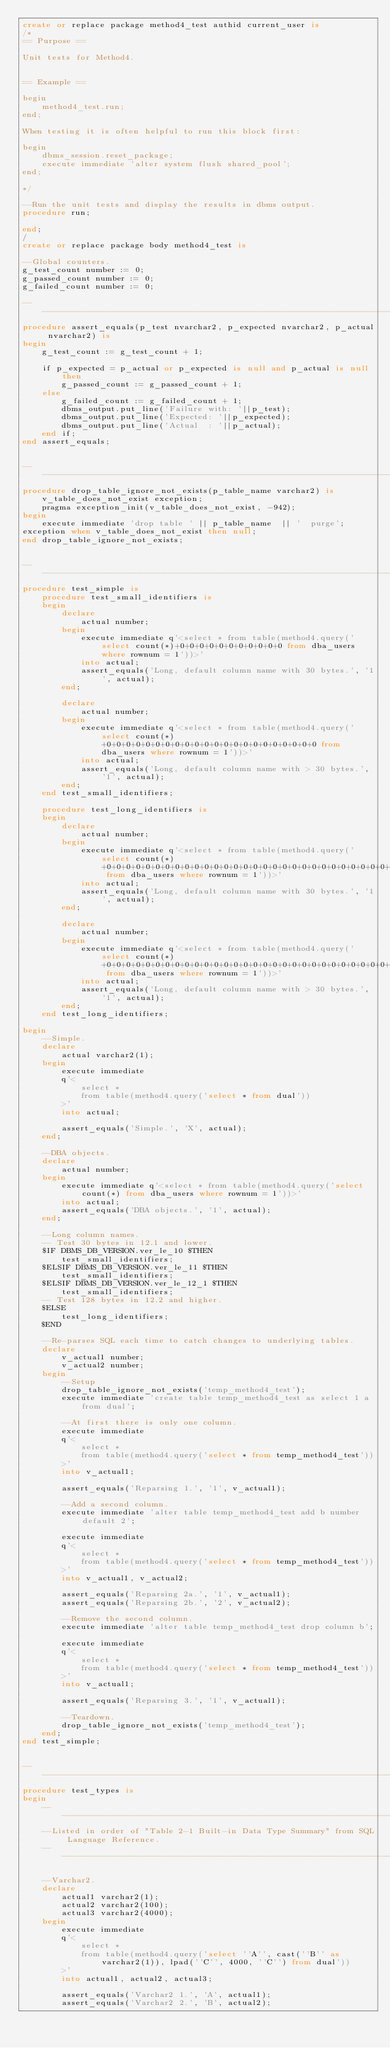<code> <loc_0><loc_0><loc_500><loc_500><_SQL_>create or replace package method4_test authid current_user is
/*
== Purpose ==

Unit tests for Method4.


== Example ==

begin
	method4_test.run;
end;

When testing it is often helpful to run this block first:

begin
	dbms_session.reset_package;
	execute immediate 'alter system flush shared_pool';
end;

*/

--Run the unit tests and display the results in dbms output.
procedure run;

end;
/
create or replace package body method4_test is

--Global counters.
g_test_count number := 0;
g_passed_count number := 0;
g_failed_count number := 0;

--------------------------------------------------------------------------------
procedure assert_equals(p_test nvarchar2, p_expected nvarchar2, p_actual nvarchar2) is
begin
	g_test_count := g_test_count + 1;

	if p_expected = p_actual or p_expected is null and p_actual is null then
		g_passed_count := g_passed_count + 1;
	else
		g_failed_count := g_failed_count + 1;
		dbms_output.put_line('Failure with: '||p_test);
		dbms_output.put_line('Expected: '||p_expected);
		dbms_output.put_line('Actual  : '||p_actual);
	end if;
end assert_equals;


--------------------------------------------------------------------------------
procedure drop_table_ignore_not_exists(p_table_name varchar2) is
	v_table_does_not_exist exception;
	pragma exception_init(v_table_does_not_exist, -942);
begin
	execute immediate 'drop table ' || p_table_name  || '  purge';
exception when v_table_does_not_exist then null;
end drop_table_ignore_not_exists;


--------------------------------------------------------------------------------
procedure test_simple is
	procedure test_small_identifiers is
	begin
		declare
			actual number;
		begin
			execute immediate q'<select * from table(method4.query('select count(*)+0+0+0+0+0+0+0+0+0+0+0 from dba_users where rownum = 1'))>'
			into actual;
			assert_equals('Long, default column name with 30 bytes.', '1', actual);
		end;

		declare
			actual number;
		begin
			execute immediate q'<select * from table(method4.query('select count(*)+0+0+0+0+0+0+0+0+0+0+0+0+0+0+0+0+0+0+0+0+0+0 from dba_users where rownum = 1'))>'
			into actual;
			assert_equals('Long, default column name with > 30 bytes.', '1', actual);
		end;
	end test_small_identifiers;

	procedure test_long_identifiers is
	begin
		declare
			actual number;
		begin
			execute immediate q'<select * from table(method4.query('select count(*)+0+0+0+0+0+0+0+0+0+0+0+0+0+0+0+0+0+0+0+0+0+0+0+0+0+0+0+0+0+0+0+0+0+0+0+0+0+0+0+0+0+0+0+0+0+0+0+0+0+0+0+0+0+0+0+0+0+0+0+0 from dba_users where rownum = 1'))>'
			into actual;
			assert_equals('Long, default column name with 30 bytes.', '1', actual);
		end;

		declare
			actual number;
		begin
			execute immediate q'<select * from table(method4.query('select count(*)+0+0+0+0+0+0+0+0+0+0+0+0+0+0+0+0+0+0+0+0+0+0+0+0+0+0+0+0+0+0+0+0+0+0+0+0+0+0+0+0+0+0+0+0+0+0+0+0+0+0+0+0+0+0+0+0+0+0+0+0+0+0+0+0+0+0+0+0 from dba_users where rownum = 1'))>'
			into actual;
			assert_equals('Long, default column name with > 30 bytes.', '1', actual);
		end;
	end test_long_identifiers;

begin
	--Simple.
	declare
		actual varchar2(1);
	begin
		execute immediate
		q'<
			select *
			from table(method4.query('select * from dual'))
		>'
		into actual;

		assert_equals('Simple.', 'X', actual);
	end;

	--DBA objects.
	declare
		actual number;
	begin
		execute immediate q'<select * from table(method4.query('select count(*) from dba_users where rownum = 1'))>'
		into actual;
		assert_equals('DBA objects.', '1', actual);
	end;

	--Long column names.
	-- Test 30 bytes in 12.1 and lower.
	$IF DBMS_DB_VERSION.ver_le_10 $THEN
		test_small_identifiers;
	$ELSIF DBMS_DB_VERSION.ver_le_11 $THEN
		test_small_identifiers;
	$ELSIF DBMS_DB_VERSION.ver_le_12_1 $THEN
		test_small_identifiers;
	-- Test 128 bytes in 12.2 and higher.
	$ELSE
		test_long_identifiers;
	$END

	--Re-parses SQL each time to catch changes to underlying tables.
	declare
		v_actual1 number;
		v_actual2 number;
	begin
		--Setup
		drop_table_ignore_not_exists('temp_method4_test');
		execute immediate 'create table temp_method4_test as select 1 a from dual';

		--At first there is only one column.
		execute immediate
		q'<
			select *
			from table(method4.query('select * from temp_method4_test'))
		>'
		into v_actual1;

		assert_equals('Reparsing 1.', '1', v_actual1);

		--Add a second column.
		execute immediate 'alter table temp_method4_test add b number default 2';

		execute immediate
		q'<
			select *
			from table(method4.query('select * from temp_method4_test'))
		>'
		into v_actual1, v_actual2;

		assert_equals('Reparsing 2a.', '1', v_actual1);
		assert_equals('Reparsing 2b.', '2', v_actual2);

		--Remove the second column.
		execute immediate 'alter table temp_method4_test drop column b';

		execute immediate
		q'<
			select *
			from table(method4.query('select * from temp_method4_test'))
		>'
		into v_actual1;

		assert_equals('Reparsing 3.', '1', v_actual1);

		--Teardown.
		drop_table_ignore_not_exists('temp_method4_test');
	end;
end test_simple;


--------------------------------------------------------------------------------
procedure test_types is
begin
	-------------------------------------------------------------------------------
	--Listed in order of "Table 2-1 Built-in Data Type Summary" from SQL Language Reference.
	-------------------------------------------------------------------------------

	--Varchar2.
	declare
		actual1 varchar2(1);
		actual2 varchar2(100);
		actual3 varchar2(4000);
	begin
		execute immediate
		q'<
			select *
			from table(method4.query('select ''A'', cast(''B'' as varchar2(1)), lpad(''C'', 4000, ''C'') from dual'))
		>'
		into actual1, actual2, actual3;

		assert_equals('Varchar2 1.', 'A', actual1);
		assert_equals('Varchar2 2.', 'B', actual2);</code> 